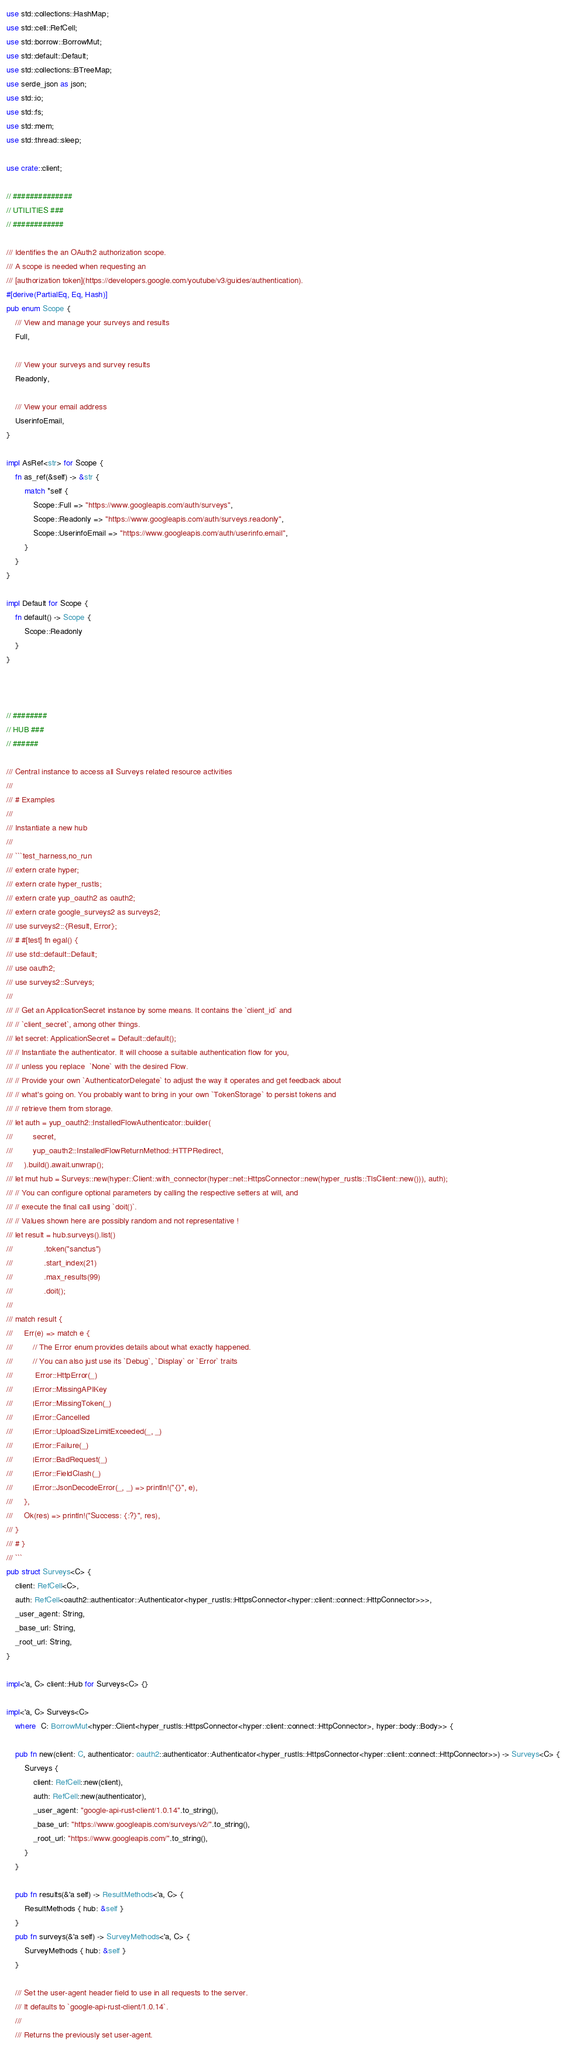<code> <loc_0><loc_0><loc_500><loc_500><_Rust_>use std::collections::HashMap;
use std::cell::RefCell;
use std::borrow::BorrowMut;
use std::default::Default;
use std::collections::BTreeMap;
use serde_json as json;
use std::io;
use std::fs;
use std::mem;
use std::thread::sleep;

use crate::client;

// ##############
// UTILITIES ###
// ############

/// Identifies the an OAuth2 authorization scope.
/// A scope is needed when requesting an
/// [authorization token](https://developers.google.com/youtube/v3/guides/authentication).
#[derive(PartialEq, Eq, Hash)]
pub enum Scope {
    /// View and manage your surveys and results
    Full,

    /// View your surveys and survey results
    Readonly,

    /// View your email address
    UserinfoEmail,
}

impl AsRef<str> for Scope {
    fn as_ref(&self) -> &str {
        match *self {
            Scope::Full => "https://www.googleapis.com/auth/surveys",
            Scope::Readonly => "https://www.googleapis.com/auth/surveys.readonly",
            Scope::UserinfoEmail => "https://www.googleapis.com/auth/userinfo.email",
        }
    }
}

impl Default for Scope {
    fn default() -> Scope {
        Scope::Readonly
    }
}



// ########
// HUB ###
// ######

/// Central instance to access all Surveys related resource activities
///
/// # Examples
///
/// Instantiate a new hub
///
/// ```test_harness,no_run
/// extern crate hyper;
/// extern crate hyper_rustls;
/// extern crate yup_oauth2 as oauth2;
/// extern crate google_surveys2 as surveys2;
/// use surveys2::{Result, Error};
/// # #[test] fn egal() {
/// use std::default::Default;
/// use oauth2;
/// use surveys2::Surveys;
/// 
/// // Get an ApplicationSecret instance by some means. It contains the `client_id` and 
/// // `client_secret`, among other things.
/// let secret: ApplicationSecret = Default::default();
/// // Instantiate the authenticator. It will choose a suitable authentication flow for you, 
/// // unless you replace  `None` with the desired Flow.
/// // Provide your own `AuthenticatorDelegate` to adjust the way it operates and get feedback about 
/// // what's going on. You probably want to bring in your own `TokenStorage` to persist tokens and
/// // retrieve them from storage.
/// let auth = yup_oauth2::InstalledFlowAuthenticator::builder(
///         secret,
///         yup_oauth2::InstalledFlowReturnMethod::HTTPRedirect,
///     ).build().await.unwrap();
/// let mut hub = Surveys::new(hyper::Client::with_connector(hyper::net::HttpsConnector::new(hyper_rustls::TlsClient::new())), auth);
/// // You can configure optional parameters by calling the respective setters at will, and
/// // execute the final call using `doit()`.
/// // Values shown here are possibly random and not representative !
/// let result = hub.surveys().list()
///              .token("sanctus")
///              .start_index(21)
///              .max_results(99)
///              .doit();
/// 
/// match result {
///     Err(e) => match e {
///         // The Error enum provides details about what exactly happened.
///         // You can also just use its `Debug`, `Display` or `Error` traits
///          Error::HttpError(_)
///         |Error::MissingAPIKey
///         |Error::MissingToken(_)
///         |Error::Cancelled
///         |Error::UploadSizeLimitExceeded(_, _)
///         |Error::Failure(_)
///         |Error::BadRequest(_)
///         |Error::FieldClash(_)
///         |Error::JsonDecodeError(_, _) => println!("{}", e),
///     },
///     Ok(res) => println!("Success: {:?}", res),
/// }
/// # }
/// ```
pub struct Surveys<C> {
    client: RefCell<C>,
    auth: RefCell<oauth2::authenticator::Authenticator<hyper_rustls::HttpsConnector<hyper::client::connect::HttpConnector>>>,
    _user_agent: String,
    _base_url: String,
    _root_url: String,
}

impl<'a, C> client::Hub for Surveys<C> {}

impl<'a, C> Surveys<C>
    where  C: BorrowMut<hyper::Client<hyper_rustls::HttpsConnector<hyper::client::connect::HttpConnector>, hyper::body::Body>> {

    pub fn new(client: C, authenticator: oauth2::authenticator::Authenticator<hyper_rustls::HttpsConnector<hyper::client::connect::HttpConnector>>) -> Surveys<C> {
        Surveys {
            client: RefCell::new(client),
            auth: RefCell::new(authenticator),
            _user_agent: "google-api-rust-client/1.0.14".to_string(),
            _base_url: "https://www.googleapis.com/surveys/v2/".to_string(),
            _root_url: "https://www.googleapis.com/".to_string(),
        }
    }

    pub fn results(&'a self) -> ResultMethods<'a, C> {
        ResultMethods { hub: &self }
    }
    pub fn surveys(&'a self) -> SurveyMethods<'a, C> {
        SurveyMethods { hub: &self }
    }

    /// Set the user-agent header field to use in all requests to the server.
    /// It defaults to `google-api-rust-client/1.0.14`.
    ///
    /// Returns the previously set user-agent.</code> 